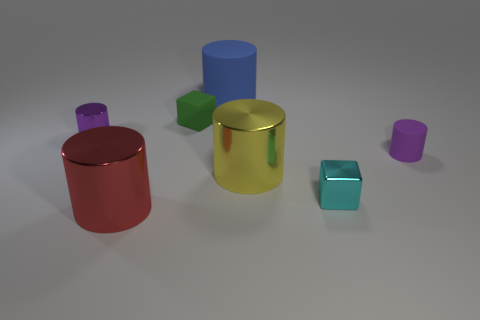What color is the large metal thing right of the cylinder that is behind the green cube?
Your answer should be compact. Yellow. What number of yellow metallic cylinders are there?
Provide a short and direct response. 1. Do the large matte object and the tiny rubber cylinder have the same color?
Your response must be concise. No. Are there fewer large blue cylinders that are left of the large matte cylinder than small purple cylinders on the left side of the purple matte cylinder?
Your answer should be compact. Yes. The matte block is what color?
Keep it short and to the point. Green. What number of rubber things are the same color as the tiny metallic cylinder?
Give a very brief answer. 1. Are there any purple metallic cylinders behind the small purple matte object?
Offer a very short reply. Yes. Are there an equal number of small matte cylinders in front of the small metal cube and blocks that are right of the blue thing?
Your answer should be compact. No. Do the object in front of the tiny cyan cube and the purple metal cylinder on the left side of the tiny metallic block have the same size?
Your answer should be compact. No. What is the shape of the large thing that is behind the tiny purple cylinder that is to the left of the tiny metal block on the right side of the big yellow shiny thing?
Your answer should be compact. Cylinder. 